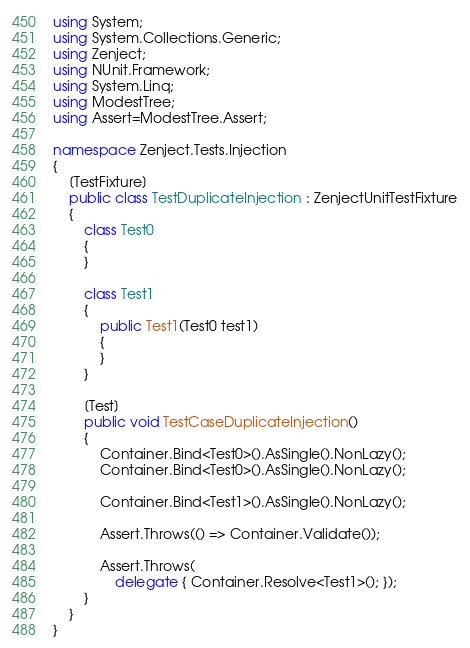<code> <loc_0><loc_0><loc_500><loc_500><_C#_>using System;
using System.Collections.Generic;
using Zenject;
using NUnit.Framework;
using System.Linq;
using ModestTree;
using Assert=ModestTree.Assert;

namespace Zenject.Tests.Injection
{
    [TestFixture]
    public class TestDuplicateInjection : ZenjectUnitTestFixture
    {
        class Test0
        {
        }

        class Test1
        {
            public Test1(Test0 test1)
            {
            }
        }

        [Test]
        public void TestCaseDuplicateInjection()
        {
            Container.Bind<Test0>().AsSingle().NonLazy();
            Container.Bind<Test0>().AsSingle().NonLazy();

            Container.Bind<Test1>().AsSingle().NonLazy();

            Assert.Throws(() => Container.Validate());

            Assert.Throws(
                delegate { Container.Resolve<Test1>(); });
        }
    }
}


</code> 